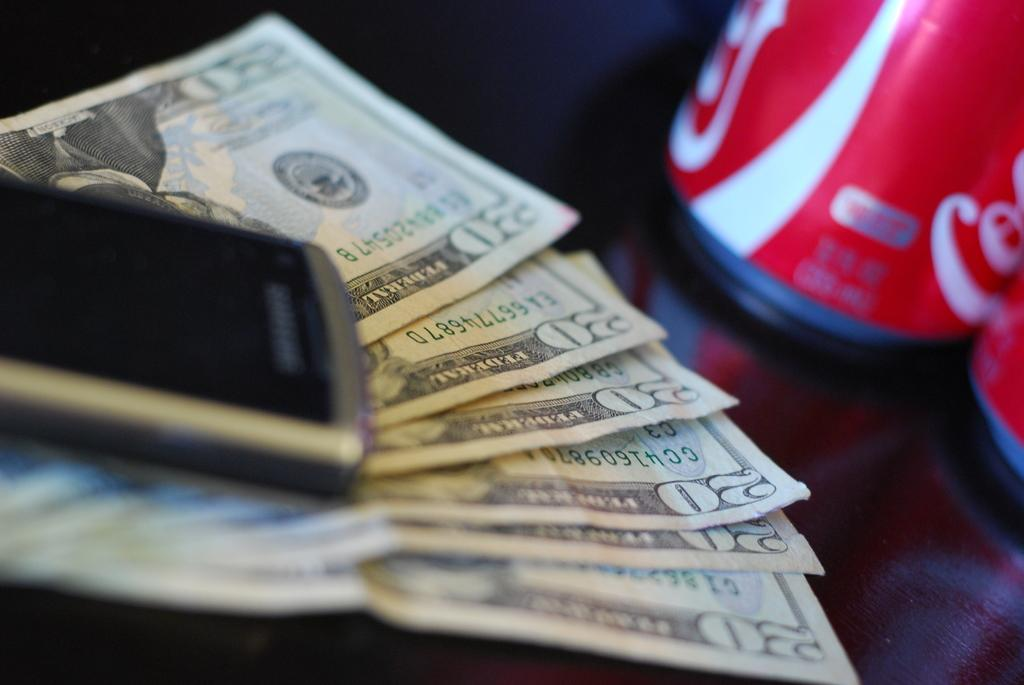<image>
Provide a brief description of the given image. A stack of 20 dollar bills under a cell phone 